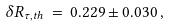Convert formula to latex. <formula><loc_0><loc_0><loc_500><loc_500>\delta R _ { \tau , t h } \, = \, 0 . 2 2 9 \pm 0 . 0 3 0 \, ,</formula> 